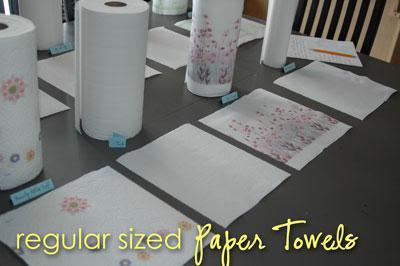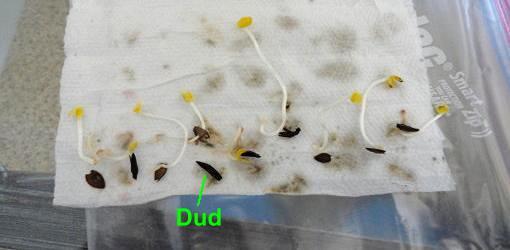The first image is the image on the left, the second image is the image on the right. Given the left and right images, does the statement "An image shows one towel row mounted horizontally, with a sheet hanging toward the left." hold true? Answer yes or no. No. The first image is the image on the left, the second image is the image on the right. For the images shown, is this caption "In one image, a roll of paper towels is attached to a chrome hanging towel holder, while a second image shows a roll of paper towels on an upright towel holder." true? Answer yes or no. No. 